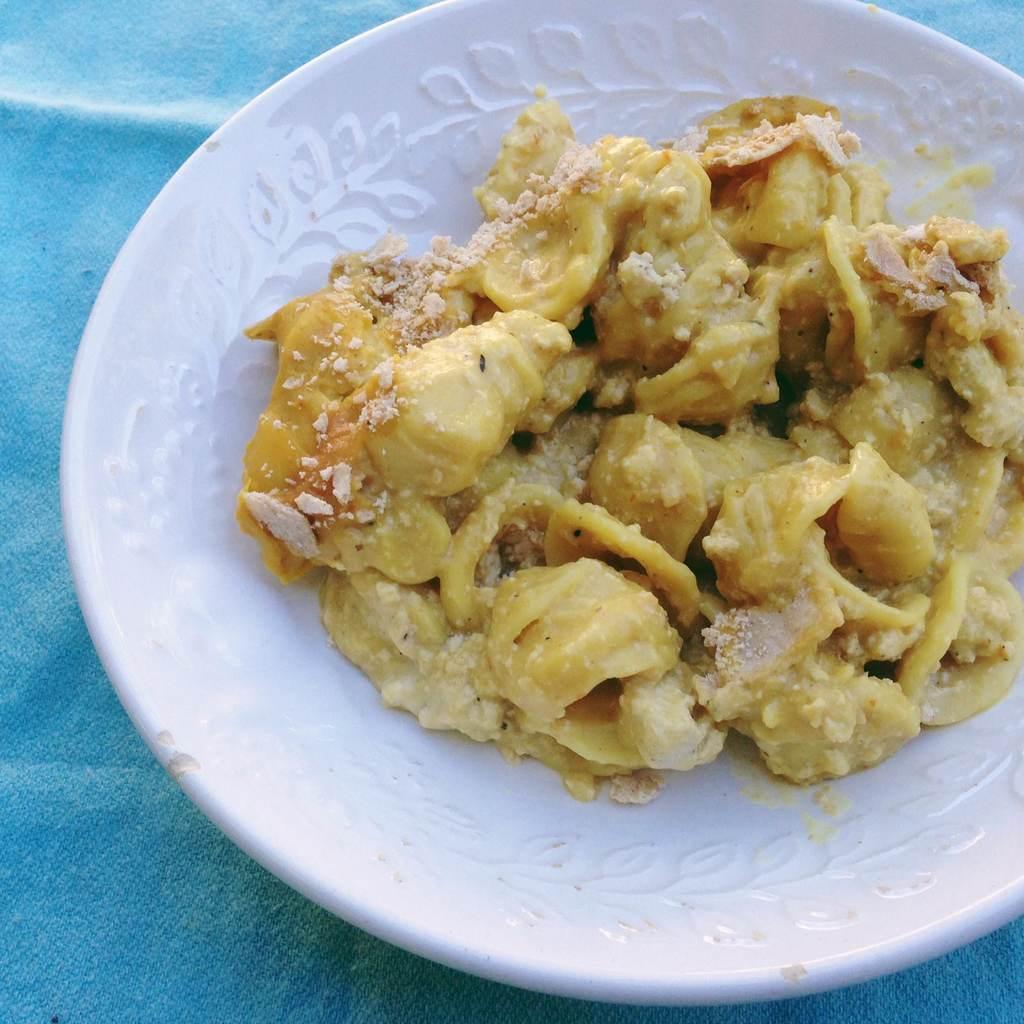Please provide a concise description of this image. In this image I can see food items on a plate may be kept on a table. This image is taken may be in a room. 